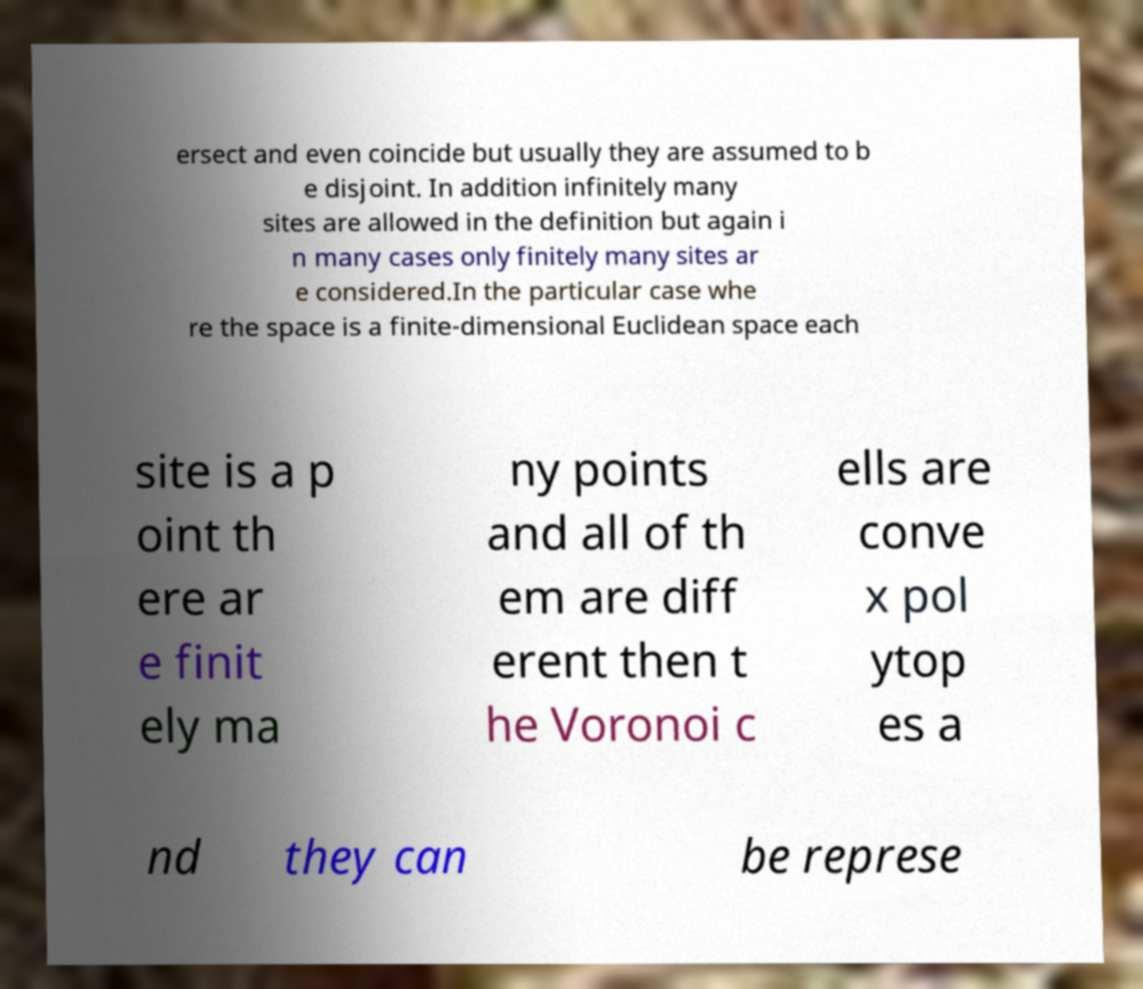There's text embedded in this image that I need extracted. Can you transcribe it verbatim? ersect and even coincide but usually they are assumed to b e disjoint. In addition infinitely many sites are allowed in the definition but again i n many cases only finitely many sites ar e considered.In the particular case whe re the space is a finite-dimensional Euclidean space each site is a p oint th ere ar e finit ely ma ny points and all of th em are diff erent then t he Voronoi c ells are conve x pol ytop es a nd they can be represe 